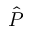Convert formula to latex. <formula><loc_0><loc_0><loc_500><loc_500>\hat { P }</formula> 